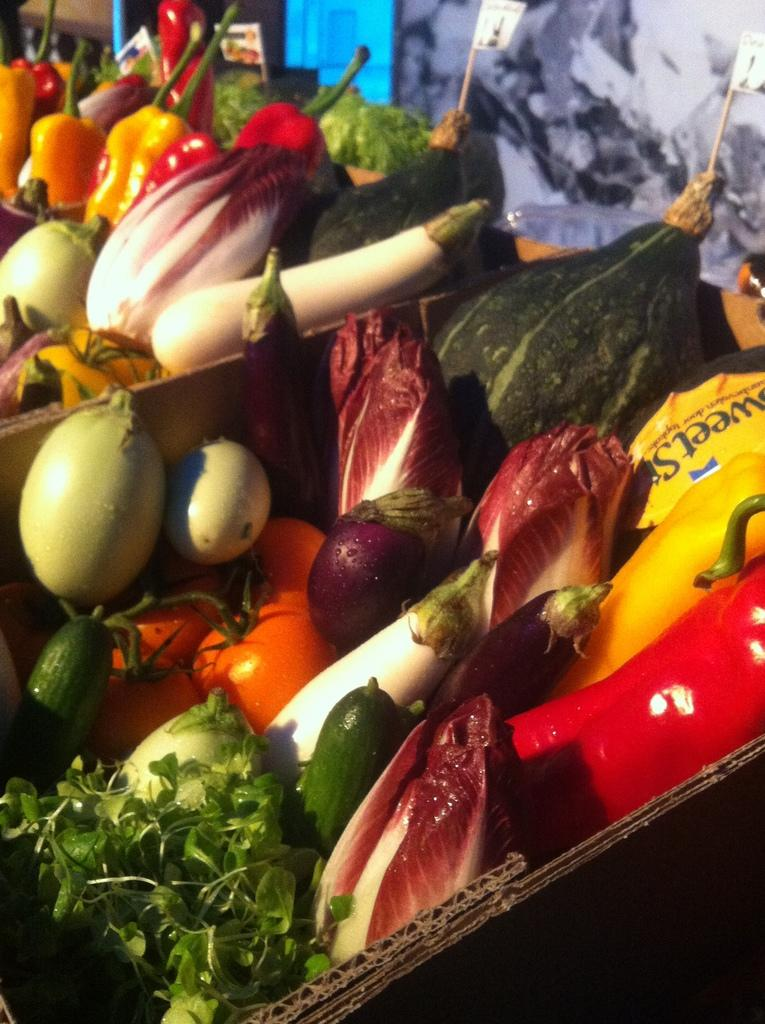What material is visible in the image? There is cardboard in the image. What type of food items can be seen in the image? There are vegetables present in the image. Can you describe the background of the image? The background of the image is blurry. Where is a specific vegetable located in the image? There is a leafy vegetable at the left bottom of the image. What type of baseball equipment can be seen in the image? There is no baseball equipment present in the image. Can you describe the basin used for washing vegetables in the image? There is no basin visible in the image. 